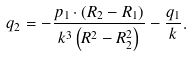Convert formula to latex. <formula><loc_0><loc_0><loc_500><loc_500>q _ { 2 } = - \frac { p _ { 1 } \cdot \left ( R _ { 2 } - R _ { 1 } \right ) } { k ^ { 3 } \left ( R ^ { 2 } - R _ { 2 } ^ { 2 } \right ) } - \frac { q _ { 1 } } { k } .</formula> 